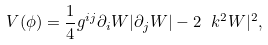<formula> <loc_0><loc_0><loc_500><loc_500>V ( \phi ) = \frac { 1 } { 4 } g ^ { i j } \partial _ { i } W | \partial _ { j } W | - 2 \ k ^ { 2 } W | ^ { 2 } ,</formula> 